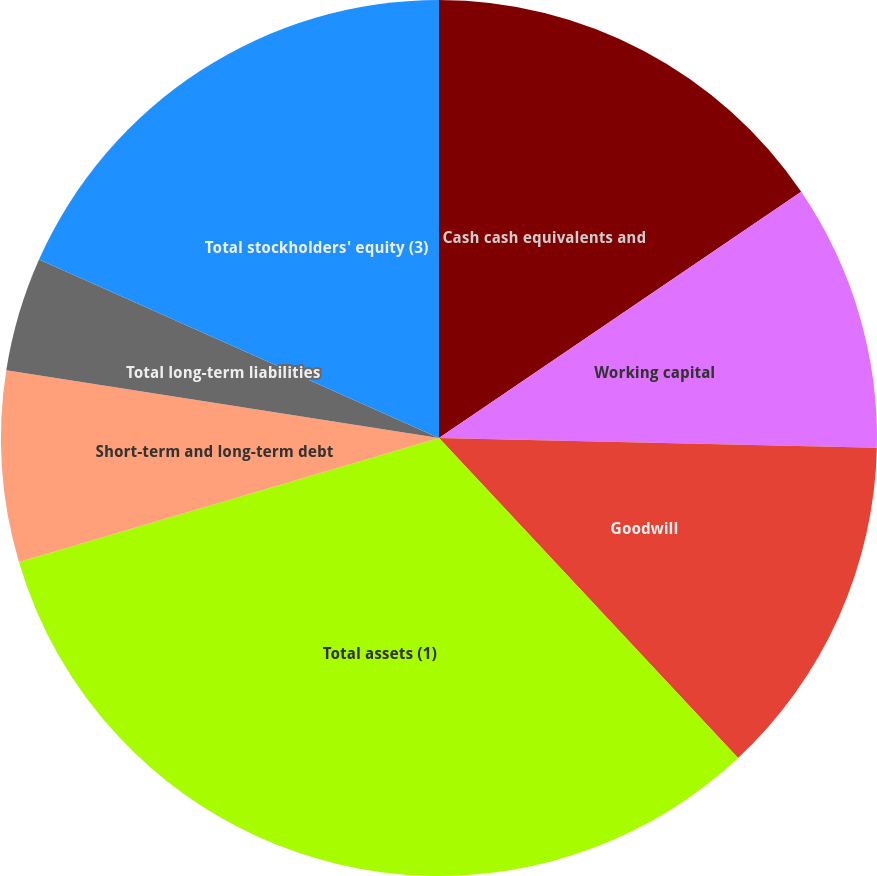<chart> <loc_0><loc_0><loc_500><loc_500><pie_chart><fcel>Cash cash equivalents and<fcel>Working capital<fcel>Goodwill<fcel>Total assets (1)<fcel>Short-term and long-term debt<fcel>Total long-term liabilities<fcel>Total stockholders' equity (3)<nl><fcel>15.5%<fcel>9.86%<fcel>12.68%<fcel>32.4%<fcel>7.04%<fcel>4.21%<fcel>18.32%<nl></chart> 